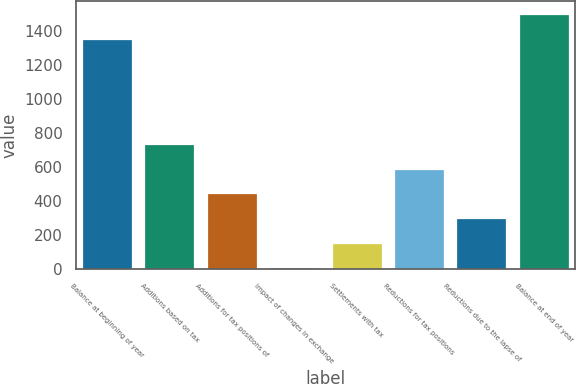Convert chart. <chart><loc_0><loc_0><loc_500><loc_500><bar_chart><fcel>Balance at beginning of year<fcel>Additions based on tax<fcel>Additions for tax positions of<fcel>Impact of changes in exchange<fcel>Settlements with tax<fcel>Reductions for tax positions<fcel>Reductions due to the lapse of<fcel>Balance at end of year<nl><fcel>1353<fcel>732.5<fcel>444.3<fcel>12<fcel>156.1<fcel>588.4<fcel>300.2<fcel>1497.1<nl></chart> 